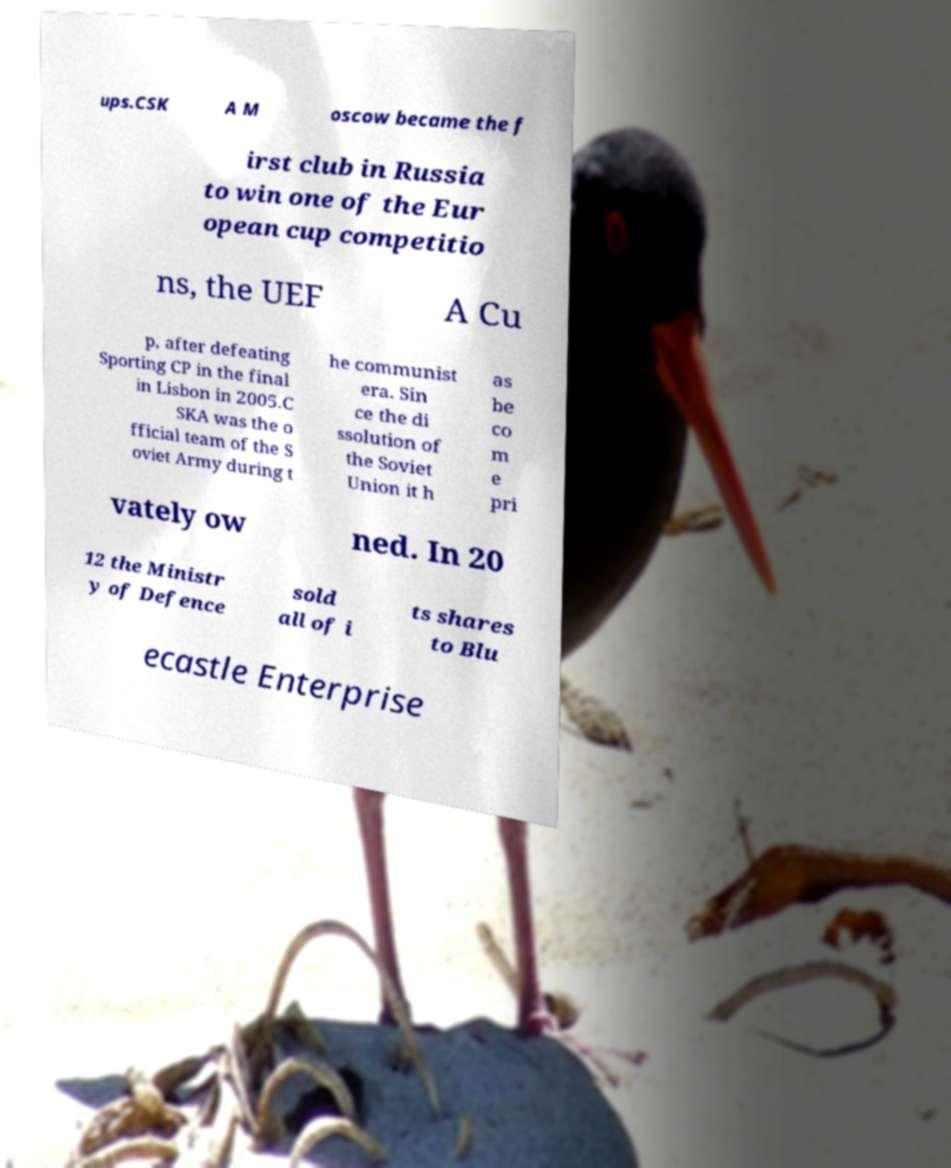Please read and relay the text visible in this image. What does it say? ups.CSK A M oscow became the f irst club in Russia to win one of the Eur opean cup competitio ns, the UEF A Cu p, after defeating Sporting CP in the final in Lisbon in 2005.C SKA was the o fficial team of the S oviet Army during t he communist era. Sin ce the di ssolution of the Soviet Union it h as be co m e pri vately ow ned. In 20 12 the Ministr y of Defence sold all of i ts shares to Blu ecastle Enterprise 